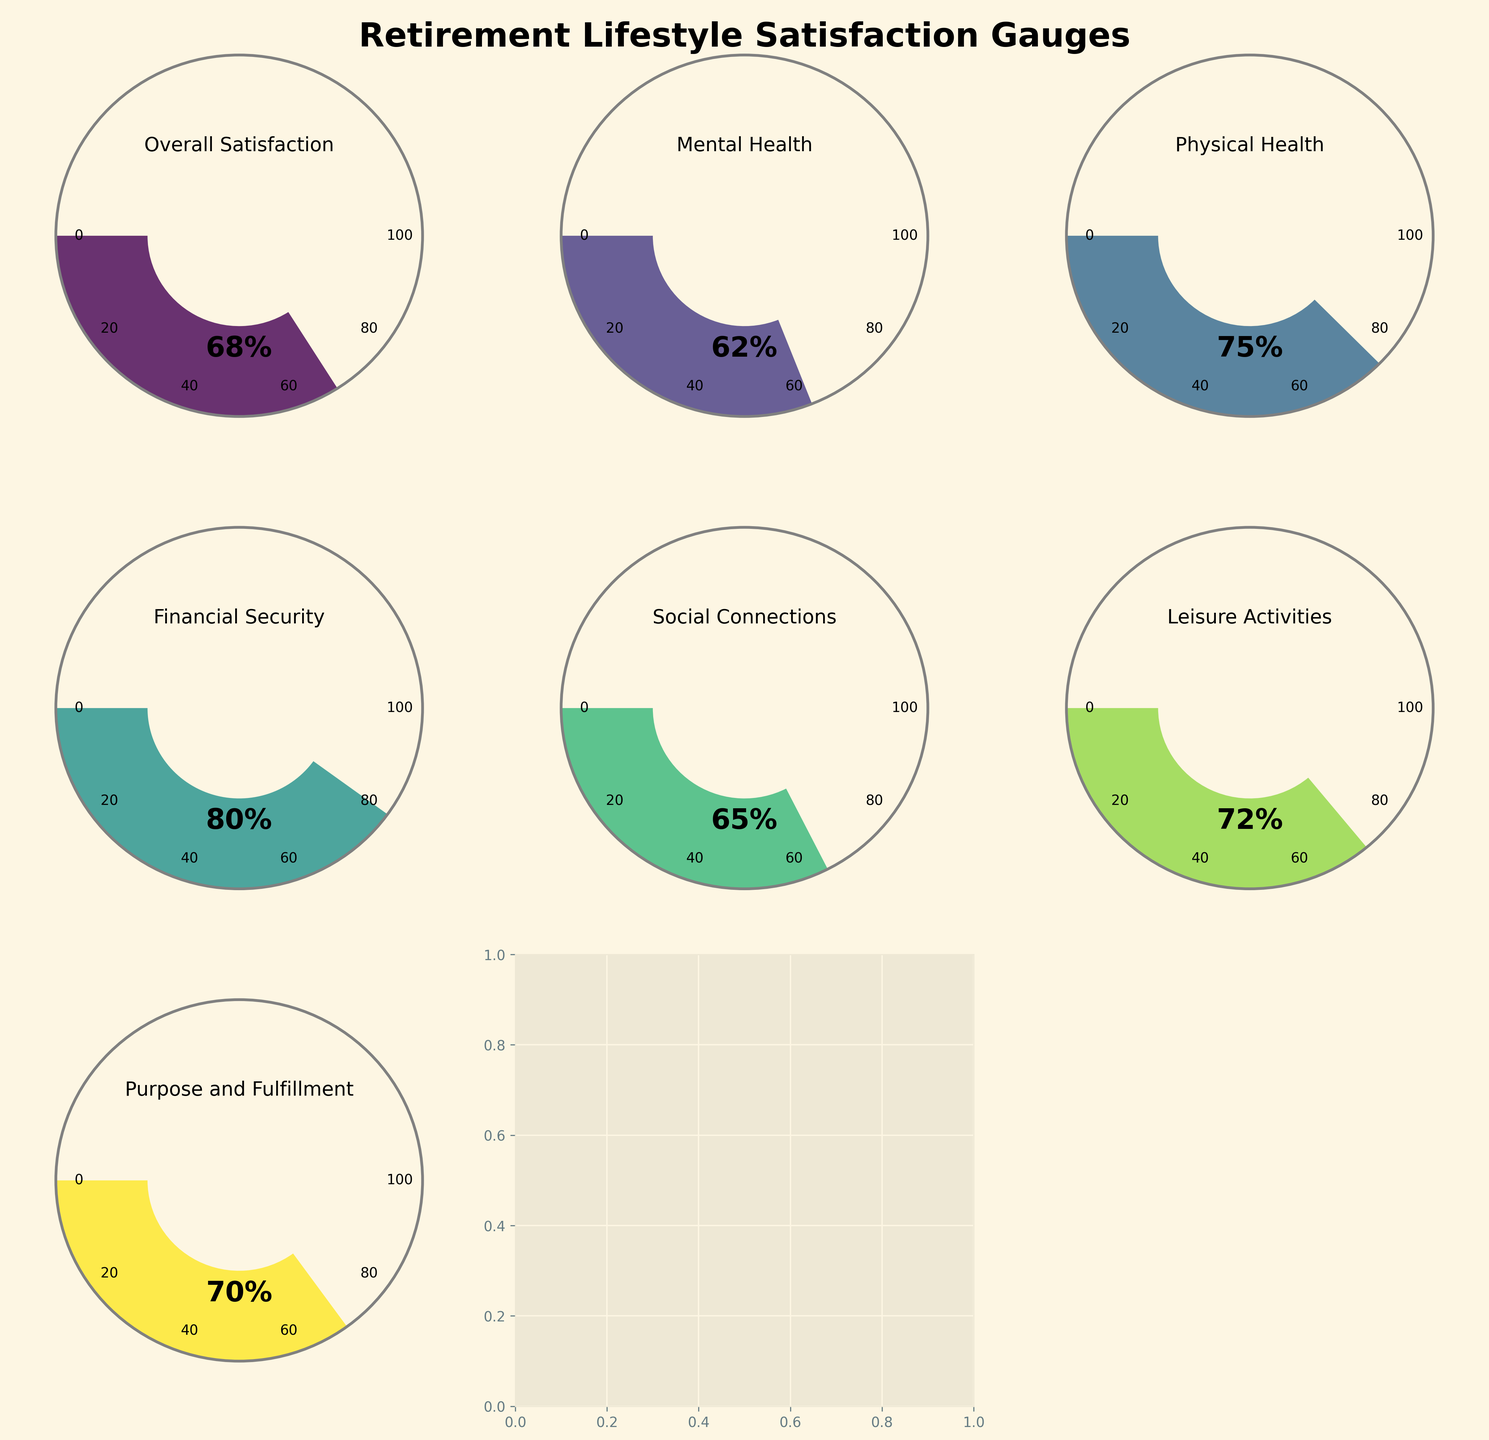What's the overall satisfaction with retirement lifestyle? Look at the gauge labeled 'Overall Satisfaction'; it shows the value 68%
Answer: 68% Which aspect has the highest satisfaction value? Compare the percentage values on all gauges; the 'Financial Security' gauge shows the highest value at 80%
Answer: Financial Security How does the satisfaction with social connections compare to physical health? The 'Social Connections' gauge shows 65%, and the 'Physical Health' gauge shows 75%. Therefore, satisfaction with social connections is 10% lower than physical health
Answer: Physical Health is 10% higher What is the average satisfaction value among all listed aspects? Add all the values (68% + 62% + 75% + 80% + 65% + 72% + 70%) and divide by the number of aspects (7): (68+62+75+80+65+72+70)/7 = 70.29%
Answer: 70.29% Which aspect of retirement lifestyle scored closest to the overall satisfaction value? Look at the values for all gauges and compare them to 'Overall Satisfaction' of 68%; 'Purpose and Fulfillment' at 70% is the closest
Answer: Purpose and Fulfillment What is the difference in satisfaction values between leisure activities and mental health? The 'Leisure Activities' gauge shows 72%, and the 'Mental Health' gauge shows 62%. The difference is 72% - 62% = 10%
Answer: 10% What percentage does leisure activities represent? Look at the 'Leisure Activities' gauge; it shows a value of 72%
Answer: 72% How many slices would you see on the 'Financial Security' gauge for every 20% interval? The total range (0-100%) divided by the interval (20%) gives 5 slices, but only the first four would show since the gauge ends at 100%
Answer: 4 slices What category has the lowest satisfaction value? Compare the percentage values on all gauges; the 'Mental Health' gauge shows the lowest value at 62%
Answer: Mental Health 